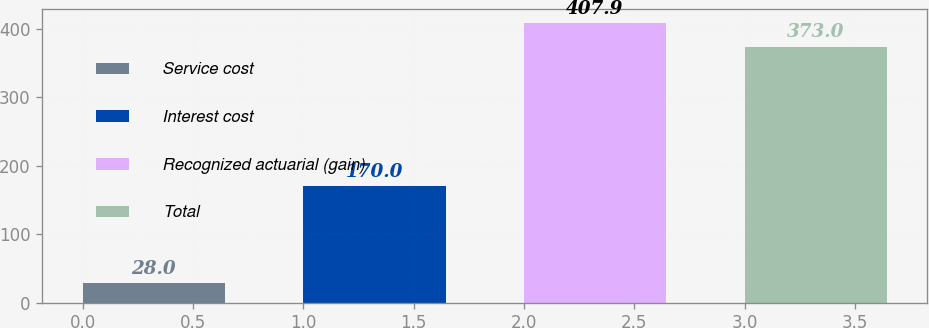Convert chart. <chart><loc_0><loc_0><loc_500><loc_500><bar_chart><fcel>Service cost<fcel>Interest cost<fcel>Recognized actuarial (gain)<fcel>Total<nl><fcel>28<fcel>170<fcel>407.9<fcel>373<nl></chart> 